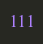<code> <loc_0><loc_0><loc_500><loc_500><_Go_>111</code> 